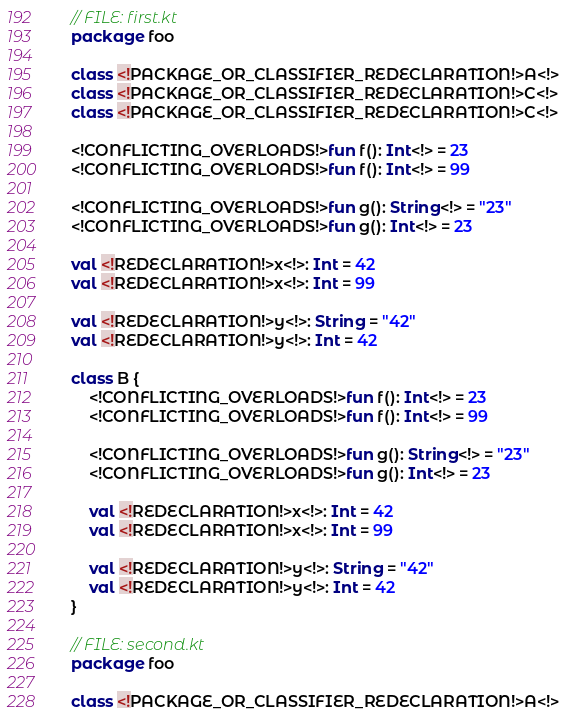<code> <loc_0><loc_0><loc_500><loc_500><_Kotlin_>// FILE: first.kt
package foo

class <!PACKAGE_OR_CLASSIFIER_REDECLARATION!>A<!>
class <!PACKAGE_OR_CLASSIFIER_REDECLARATION!>C<!>
class <!PACKAGE_OR_CLASSIFIER_REDECLARATION!>C<!>

<!CONFLICTING_OVERLOADS!>fun f(): Int<!> = 23
<!CONFLICTING_OVERLOADS!>fun f(): Int<!> = 99

<!CONFLICTING_OVERLOADS!>fun g(): String<!> = "23"
<!CONFLICTING_OVERLOADS!>fun g(): Int<!> = 23

val <!REDECLARATION!>x<!>: Int = 42
val <!REDECLARATION!>x<!>: Int = 99

val <!REDECLARATION!>y<!>: String = "42"
val <!REDECLARATION!>y<!>: Int = 42

class B {
    <!CONFLICTING_OVERLOADS!>fun f(): Int<!> = 23
    <!CONFLICTING_OVERLOADS!>fun f(): Int<!> = 99

    <!CONFLICTING_OVERLOADS!>fun g(): String<!> = "23"
    <!CONFLICTING_OVERLOADS!>fun g(): Int<!> = 23

    val <!REDECLARATION!>x<!>: Int = 42
    val <!REDECLARATION!>x<!>: Int = 99

    val <!REDECLARATION!>y<!>: String = "42"
    val <!REDECLARATION!>y<!>: Int = 42
}

// FILE: second.kt
package foo

class <!PACKAGE_OR_CLASSIFIER_REDECLARATION!>A<!>
</code> 